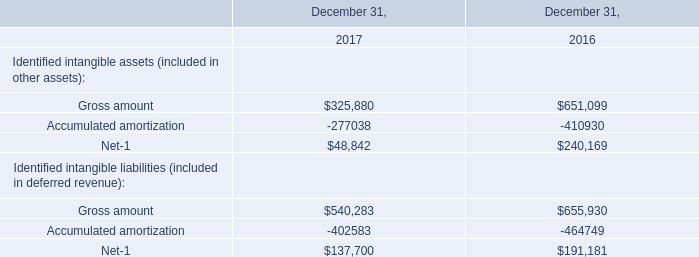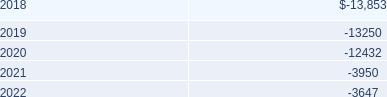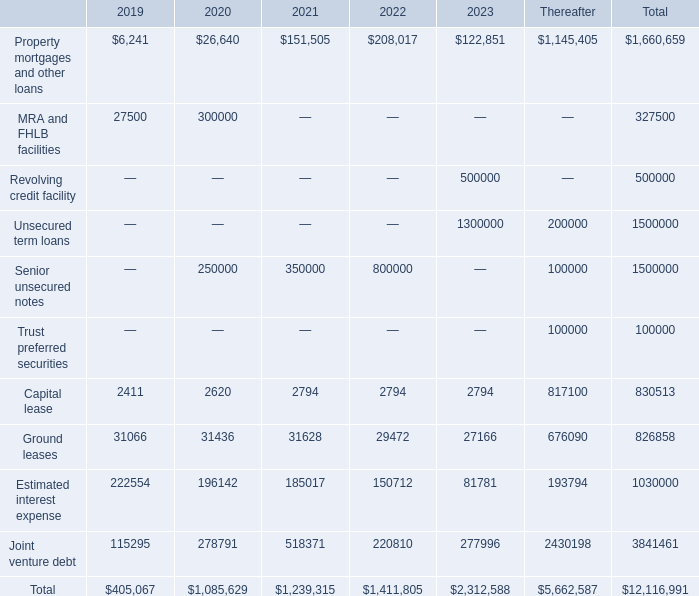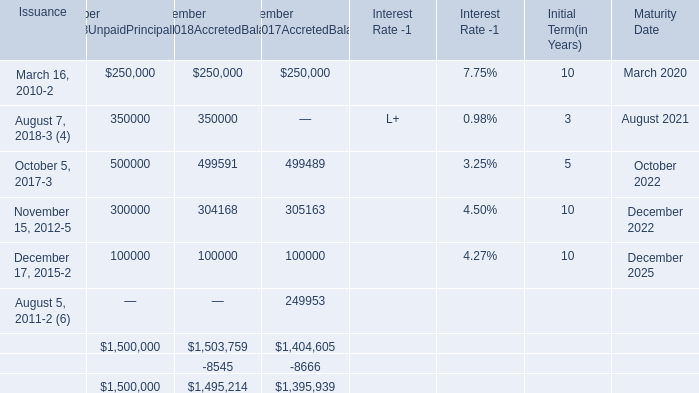What is the total amount of Property mortgages and other loans of Thereafter, November 15, 2012 of Maturity Date is, and Ground leases of Total ? 
Computations: ((1145405.0 + 2022.0) + 826858.0)
Answer: 1974285.0. 